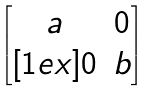Convert formula to latex. <formula><loc_0><loc_0><loc_500><loc_500>\begin{bmatrix} a & 0 \\ [ 1 e x ] 0 & b \end{bmatrix}</formula> 